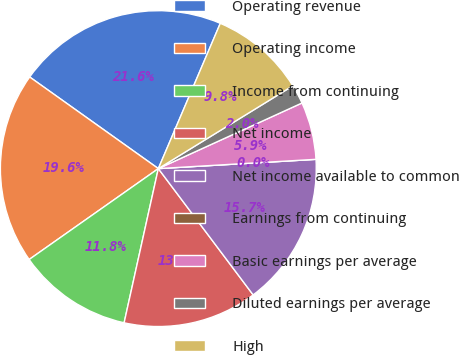<chart> <loc_0><loc_0><loc_500><loc_500><pie_chart><fcel>Operating revenue<fcel>Operating income<fcel>Income from continuing<fcel>Net income<fcel>Net income available to common<fcel>Earnings from continuing<fcel>Basic earnings per average<fcel>Diluted earnings per average<fcel>High<nl><fcel>21.56%<fcel>19.6%<fcel>11.76%<fcel>13.72%<fcel>15.68%<fcel>0.0%<fcel>5.88%<fcel>1.96%<fcel>9.8%<nl></chart> 